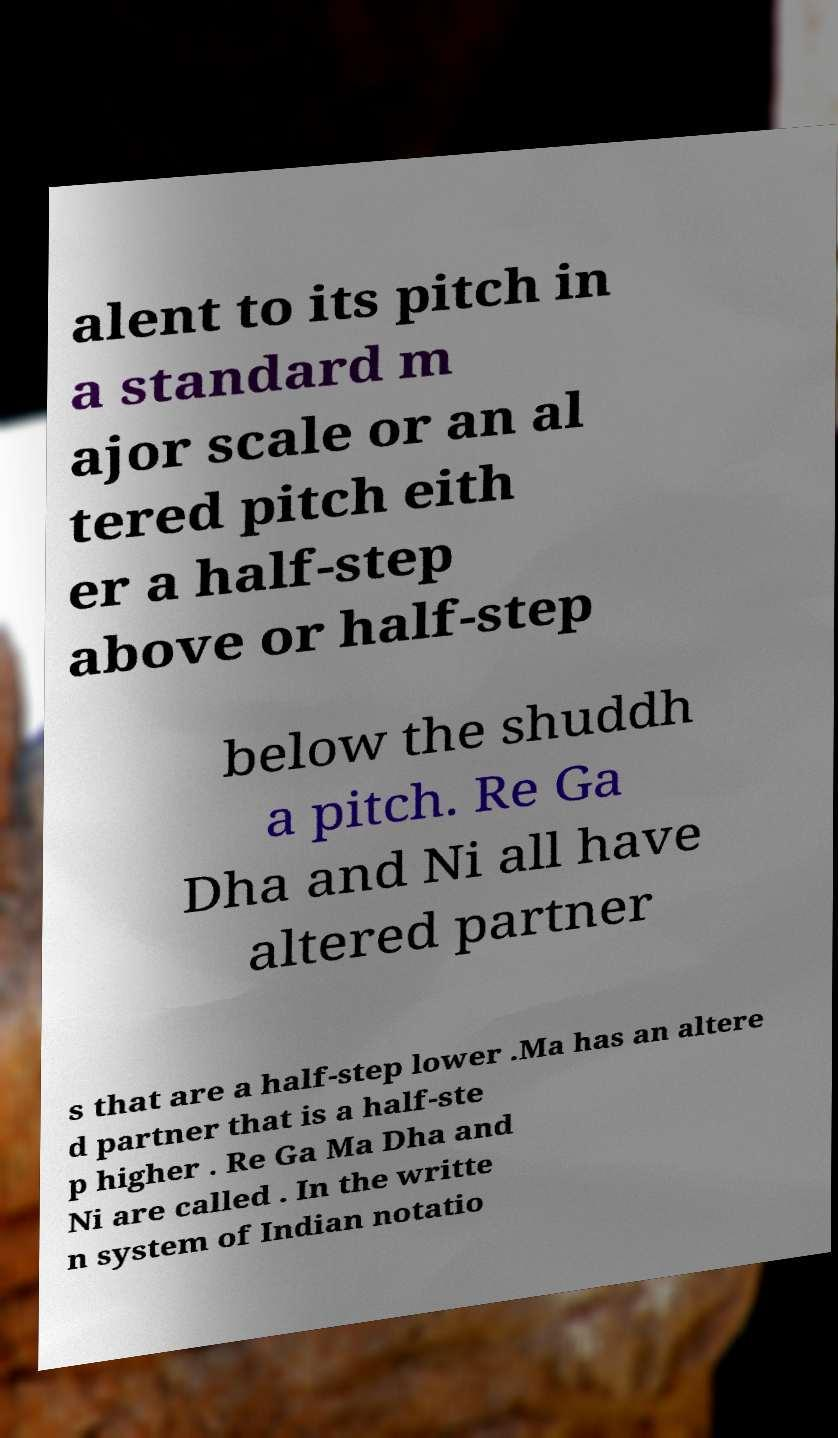I need the written content from this picture converted into text. Can you do that? alent to its pitch in a standard m ajor scale or an al tered pitch eith er a half-step above or half-step below the shuddh a pitch. Re Ga Dha and Ni all have altered partner s that are a half-step lower .Ma has an altere d partner that is a half-ste p higher . Re Ga Ma Dha and Ni are called . In the writte n system of Indian notatio 